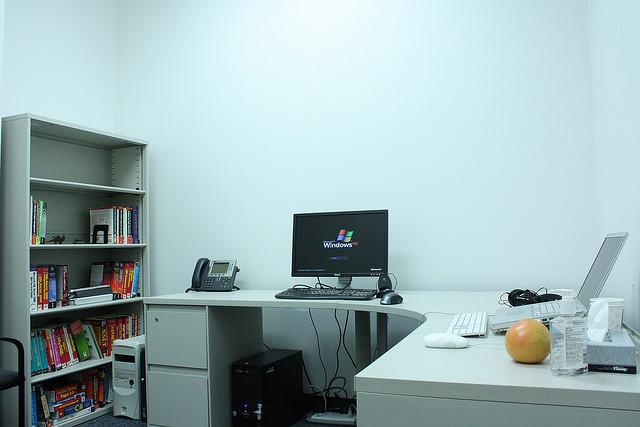What general subject do the books in the bookcase to the left of the phone cover?

Choices:
A) mathematics
B) engineering
C) history
D) information technology information technology 